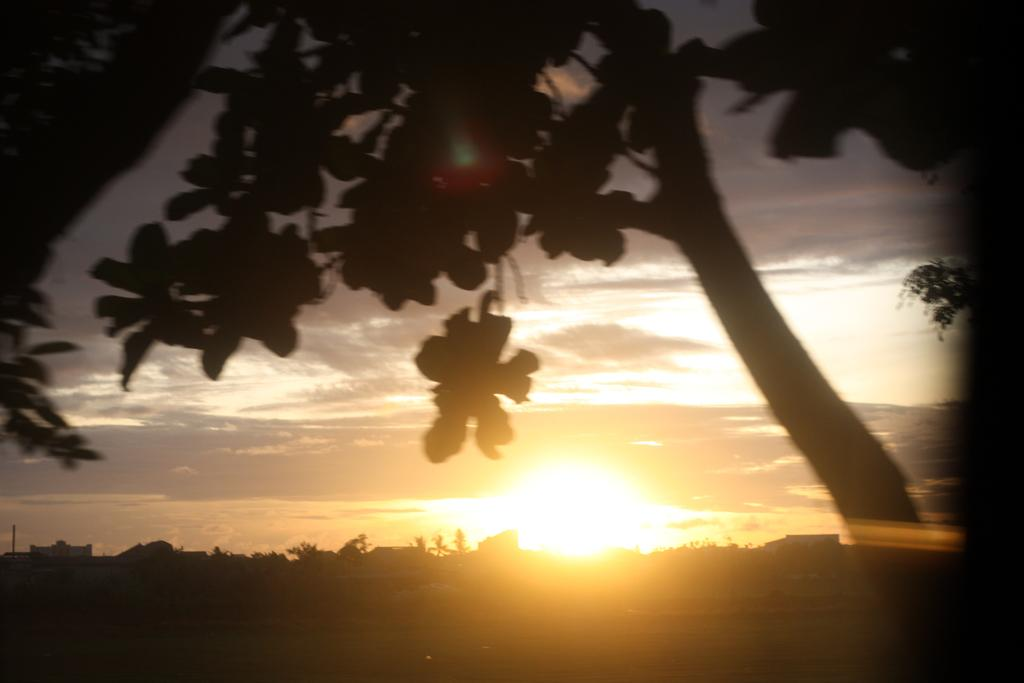What type of vegetation is present in the front of the image? There are trees in the front of the image. What can be seen in the background of the image? The sky is visible in the image. What is the condition of the sky in the image? There are clouds and the sun visible in the sky. What type of society is depicted in the image? There is no society depicted in the image; it features trees and a sky with clouds and the sun. Who is the achiever in the image? There is no individual or achievement being depicted in the image. 